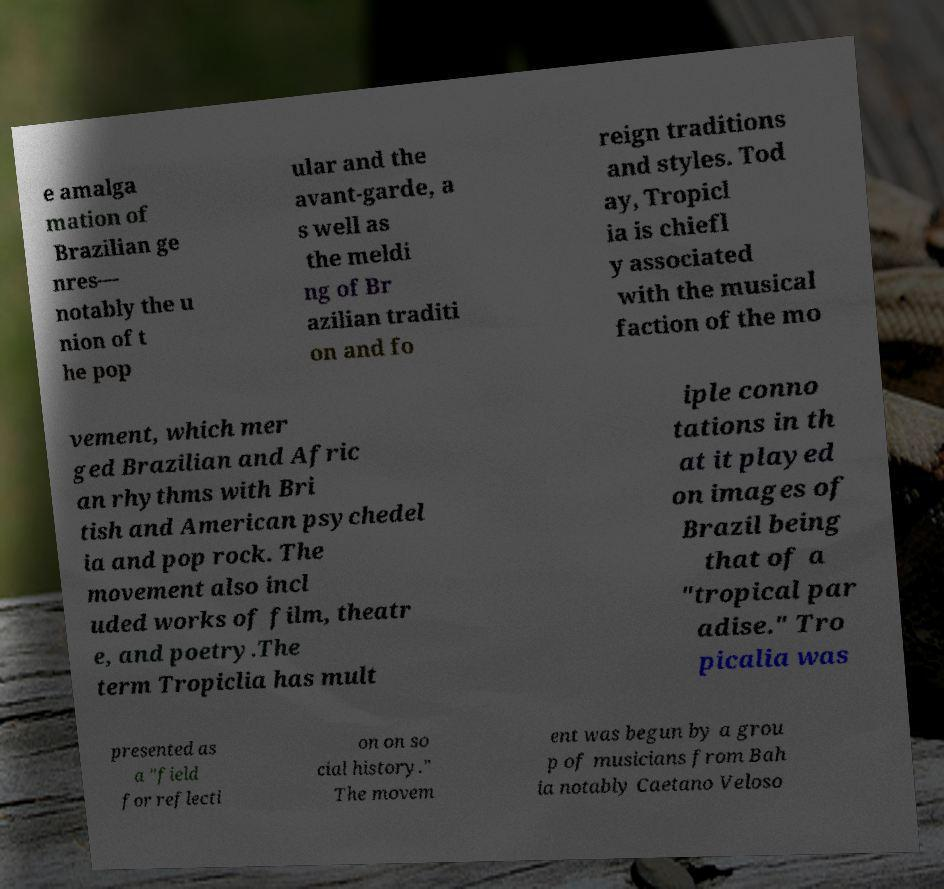Can you read and provide the text displayed in the image?This photo seems to have some interesting text. Can you extract and type it out for me? e amalga mation of Brazilian ge nres— notably the u nion of t he pop ular and the avant-garde, a s well as the meldi ng of Br azilian traditi on and fo reign traditions and styles. Tod ay, Tropicl ia is chiefl y associated with the musical faction of the mo vement, which mer ged Brazilian and Afric an rhythms with Bri tish and American psychedel ia and pop rock. The movement also incl uded works of film, theatr e, and poetry.The term Tropiclia has mult iple conno tations in th at it played on images of Brazil being that of a "tropical par adise." Tro picalia was presented as a "field for reflecti on on so cial history." The movem ent was begun by a grou p of musicians from Bah ia notably Caetano Veloso 